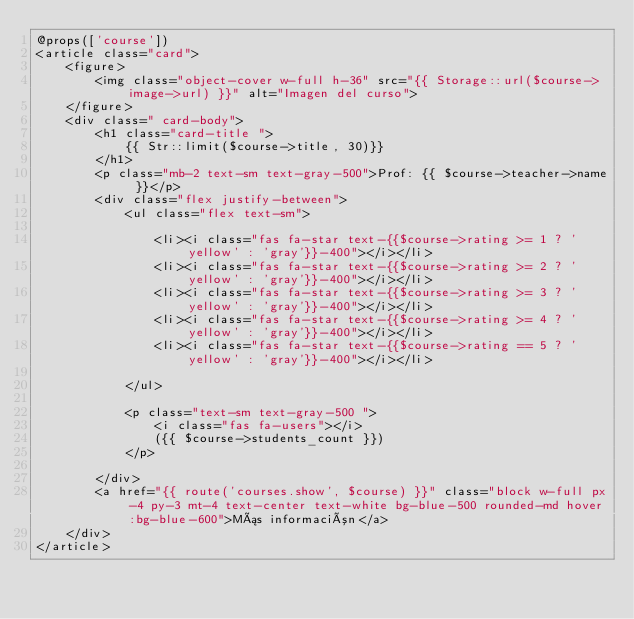<code> <loc_0><loc_0><loc_500><loc_500><_PHP_>@props(['course'])
<article class="card">
    <figure>
        <img class="object-cover w-full h-36" src="{{ Storage::url($course->image->url) }}" alt="Imagen del curso">
    </figure>
    <div class=" card-body">
        <h1 class="card-title ">
            {{ Str::limit($course->title, 30)}}
        </h1>
        <p class="mb-2 text-sm text-gray-500">Prof: {{ $course->teacher->name }}</p>
        <div class="flex justify-between">
            <ul class="flex text-sm">

                <li><i class="fas fa-star text-{{$course->rating >= 1 ? 'yellow' : 'gray'}}-400"></i></li>
                <li><i class="fas fa-star text-{{$course->rating >= 2 ? 'yellow' : 'gray'}}-400"></i></li>
                <li><i class="fas fa-star text-{{$course->rating >= 3 ? 'yellow' : 'gray'}}-400"></i></li>
                <li><i class="fas fa-star text-{{$course->rating >= 4 ? 'yellow' : 'gray'}}-400"></i></li>
                <li><i class="fas fa-star text-{{$course->rating == 5 ? 'yellow' : 'gray'}}-400"></i></li>

            </ul>

            <p class="text-sm text-gray-500 ">
                <i class="fas fa-users"></i>
                ({{ $course->students_count }})
            </p>

        </div>
        <a href="{{ route('courses.show', $course) }}" class="block w-full px-4 py-3 mt-4 text-center text-white bg-blue-500 rounded-md hover:bg-blue-600">Más información</a>
    </div>
</article>
        
</code> 